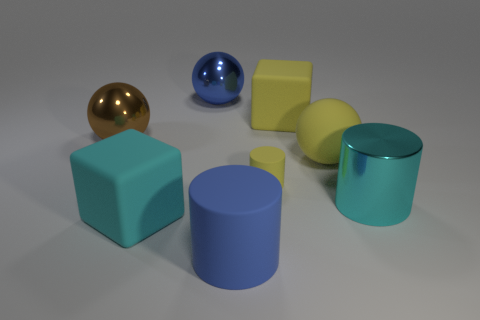What is the color of the other small matte object that is the same shape as the blue matte object?
Give a very brief answer. Yellow. There is a big shiny object right of the tiny cylinder; is it the same color as the rubber sphere?
Your answer should be very brief. No. Does the cyan cube have the same size as the cyan cylinder?
Keep it short and to the point. Yes. There is a small object that is made of the same material as the large yellow ball; what is its shape?
Ensure brevity in your answer.  Cylinder. How many other things are there of the same shape as the cyan rubber object?
Offer a very short reply. 1. There is a large cyan object that is right of the large cube that is right of the rubber object left of the blue ball; what is its shape?
Your answer should be compact. Cylinder. How many blocks are big matte objects or cyan metallic things?
Your answer should be very brief. 2. Are there any rubber blocks behind the big cylinder that is to the left of the shiny cylinder?
Ensure brevity in your answer.  Yes. Do the tiny yellow thing and the large shiny thing to the left of the blue metallic sphere have the same shape?
Make the answer very short. No. What number of other objects are the same size as the blue rubber thing?
Your answer should be very brief. 6. 